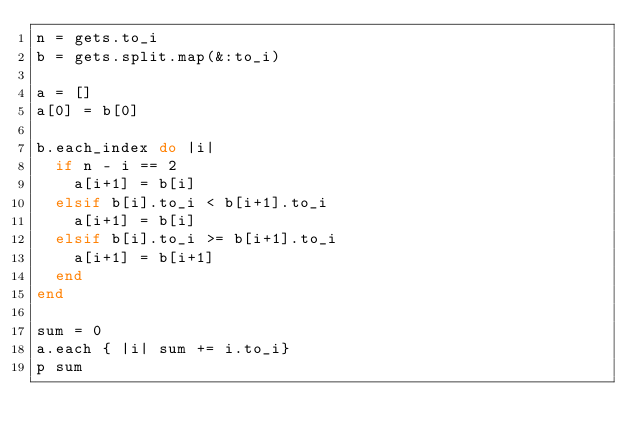Convert code to text. <code><loc_0><loc_0><loc_500><loc_500><_Ruby_>n = gets.to_i
b = gets.split.map(&:to_i)

a = []
a[0] = b[0]

b.each_index do |i|
  if n - i == 2
    a[i+1] = b[i]
  elsif b[i].to_i < b[i+1].to_i
    a[i+1] = b[i]
  elsif b[i].to_i >= b[i+1].to_i
    a[i+1] = b[i+1]
  end
end

sum = 0
a.each { |i| sum += i.to_i}
p sum
</code> 